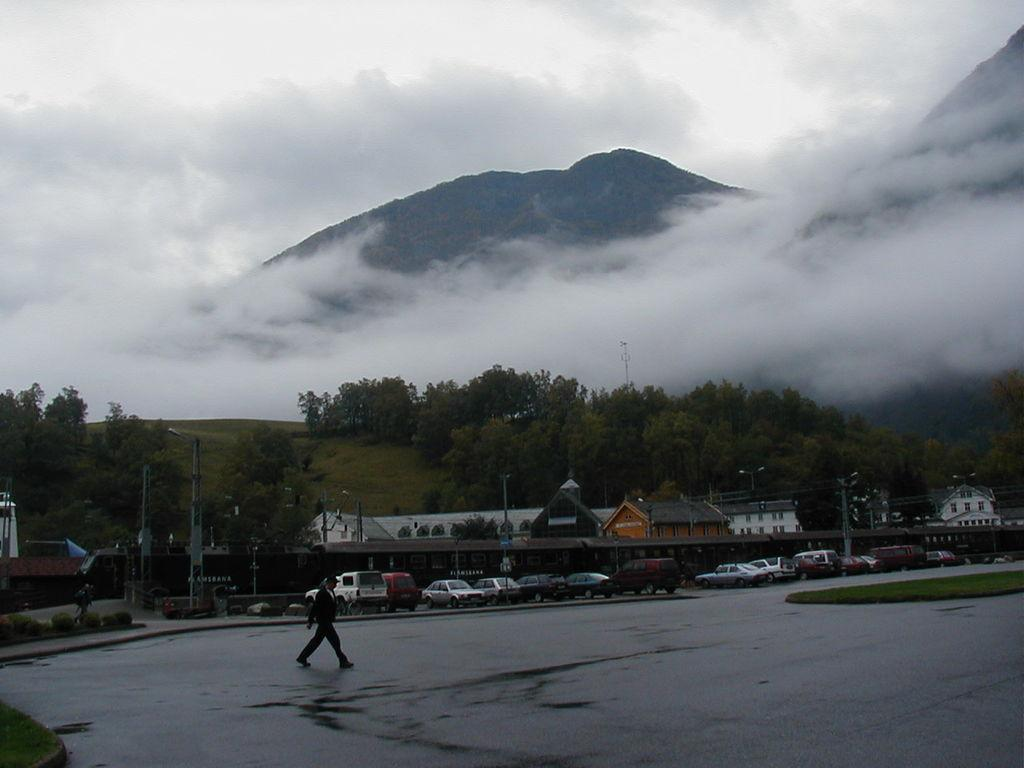What type of structures can be seen in the image? There are houses in the image. What else is present in the image besides houses? There are vehicles, a person walking on the road, poles, plants, trees, and a mountain visible in the image. Can you describe the environment in the image? The environment includes plants, trees, and a mountain, suggesting a natural setting. What is visible in the sky in the image? The sky is visible in the image. What type of stew is being served in the image? There is no stew present in the image. What time of day is it in the image, given the presence of morning light? The image does not provide any information about the time of day or the presence of morning light. 